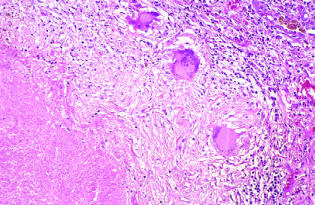what highlights the histologic features?
Answer the question using a single word or phrase. The high-magnification view 